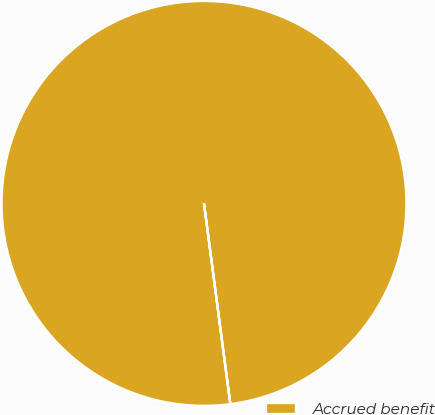Convert chart to OTSL. <chart><loc_0><loc_0><loc_500><loc_500><pie_chart><fcel>Accrued benefit<nl><fcel>100.0%<nl></chart> 